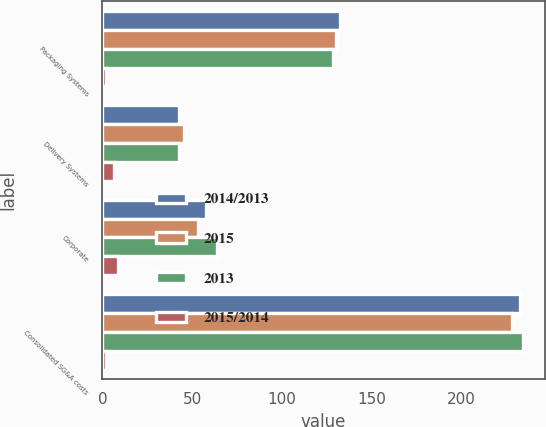<chart> <loc_0><loc_0><loc_500><loc_500><stacked_bar_chart><ecel><fcel>Packaging Systems<fcel>Delivery Systems<fcel>Corporate<fcel>Consolidated SG&A costs<nl><fcel>2014/2013<fcel>132.7<fcel>42.5<fcel>57.8<fcel>233<nl><fcel>2015<fcel>130.1<fcel>45.4<fcel>53.2<fcel>228.7<nl><fcel>2013<fcel>128.4<fcel>42.6<fcel>63.9<fcel>234.9<nl><fcel>2015/2014<fcel>2<fcel>6.4<fcel>8.6<fcel>1.9<nl></chart> 